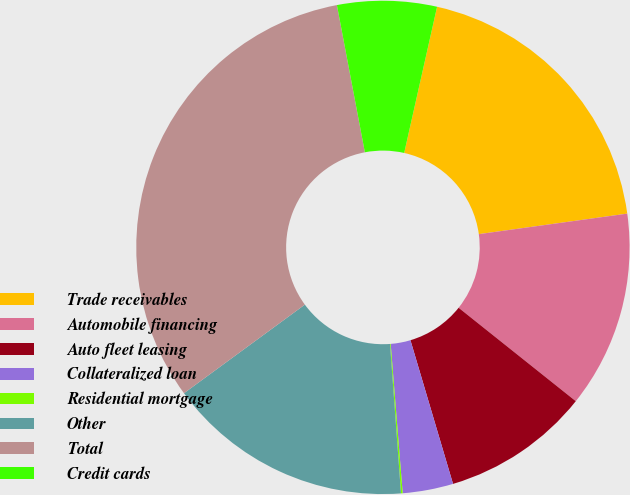<chart> <loc_0><loc_0><loc_500><loc_500><pie_chart><fcel>Trade receivables<fcel>Automobile financing<fcel>Auto fleet leasing<fcel>Collateralized loan<fcel>Residential mortgage<fcel>Other<fcel>Total<fcel>Credit cards<nl><fcel>19.29%<fcel>12.9%<fcel>9.7%<fcel>3.31%<fcel>0.11%<fcel>16.1%<fcel>32.08%<fcel>6.51%<nl></chart> 